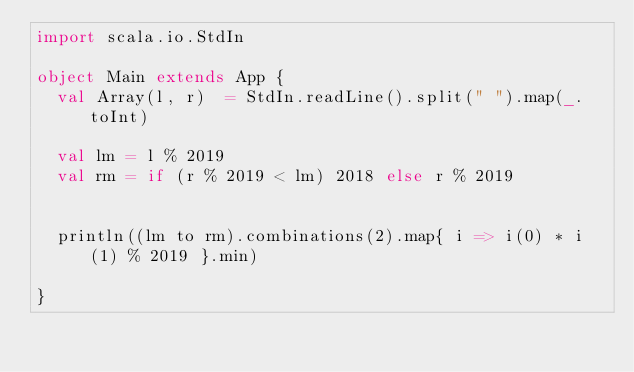Convert code to text. <code><loc_0><loc_0><loc_500><loc_500><_Scala_>import scala.io.StdIn

object Main extends App {
  val Array(l, r)  = StdIn.readLine().split(" ").map(_.toInt)

  val lm = l % 2019
  val rm = if (r % 2019 < lm) 2018 else r % 2019
  

  println((lm to rm).combinations(2).map{ i => i(0) * i(1) % 2019 }.min)

}
  

</code> 